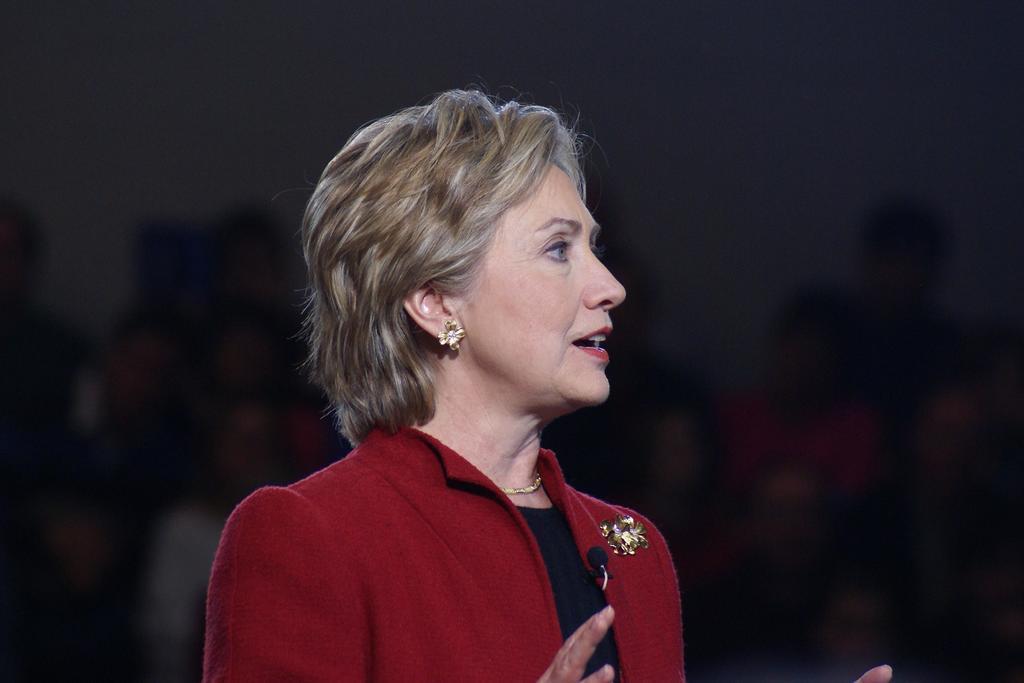How would you summarize this image in a sentence or two? Here in this picture we can see a woman standing over there, speaking something in the microphone present on her coat and we can see she is wearing a red colored coat on her. 